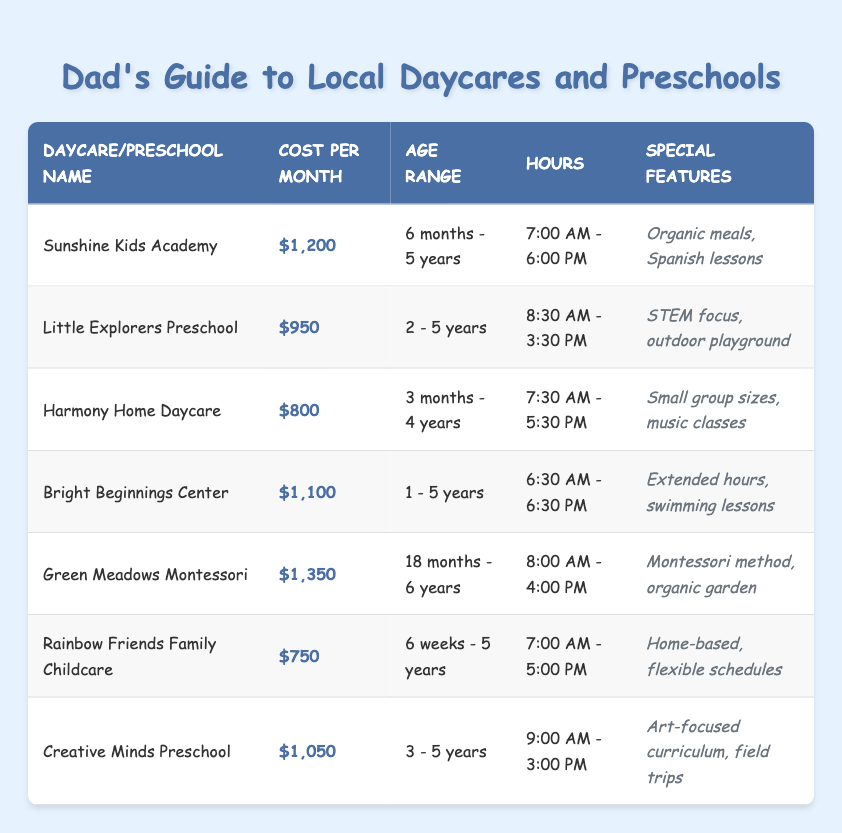What is the cost of Harmony Home Daycare? The table provides the cost of Harmony Home Daycare located in the row associated with its name. It states that the cost is $800 per month.
Answer: $800 Which daycare has the longest hours of operation? By scanning the "Hours" column, I can compare the operating hours. Bright Beginnings Center operates from 6:30 AM to 6:30 PM, which totals 12 hours, the longest among all listed facilities.
Answer: Bright Beginnings Center Are there any daycares that offer a STEM focus? Looking through the "Special Features" column, Little Explorers Preschool explicitly mentions a STEM focus, indicating it indeed offers this educational aspect.
Answer: Yes What is the average cost of the daycares listed? To calculate the average cost, first convert each cost to numerical values: $1,200, $950, $800, $1,100, $1,350, $750, $1,050. Sum these values (1,200 + 950 + 800 + 1,100 + 1,350 + 750 + 1,050 = 7,200). Then divide by the number of daycares (7), yielding an average cost of $7,200/7 = $1,028.57.
Answer: $1,028.57 Does Rainbow Friends Family Childcare have a flexible schedule option? The "Special Features" column for Rainbow Friends Family Childcare includes "flexible schedules," confirming that it does offer this option.
Answer: Yes Which daycare is the most expensive and what is its cost? The "Cost per Month" column should be reviewed to find the maximum value. Green Meadows Montessori is listed with a cost of $1,350, making it the most expensive option.
Answer: Green Meadows Montessori, $1,350 How many daycares cater to children under 2 years old? By analyzing the "Age Range" column, we take note of the age specifications. Harmony Home Daycare (3 months - 4 years) and Rainbow Friends Family Childcare (6 weeks - 5 years) both accept children under 2 years old, hence there are two such daycares.
Answer: 2 What is the common age range for most of the daycares and preschools? Upon examining the "Age Range" column, the most frequently occurring age range appears to be 3 - 5 years, as indicated by Little Explorers Preschool, Creative Minds Preschool, and Harmony Home Daycare given their age specifications.
Answer: 3 - 5 years How much more expensive is Green Meadows Montessori than Harmony Home Daycare? First, find the costs for both daycares. Green Meadows Montessori has a cost of $1,350 and Harmony Home Daycare has a cost of $800. Subtract the two values: $1,350 - $800 = $550, showing that Green Meadows Montessori is $550 more expensive.
Answer: $550 